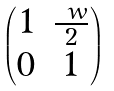Convert formula to latex. <formula><loc_0><loc_0><loc_500><loc_500>\begin{pmatrix} 1 & \frac { \ w } { 2 } \\ 0 & 1 \end{pmatrix}</formula> 